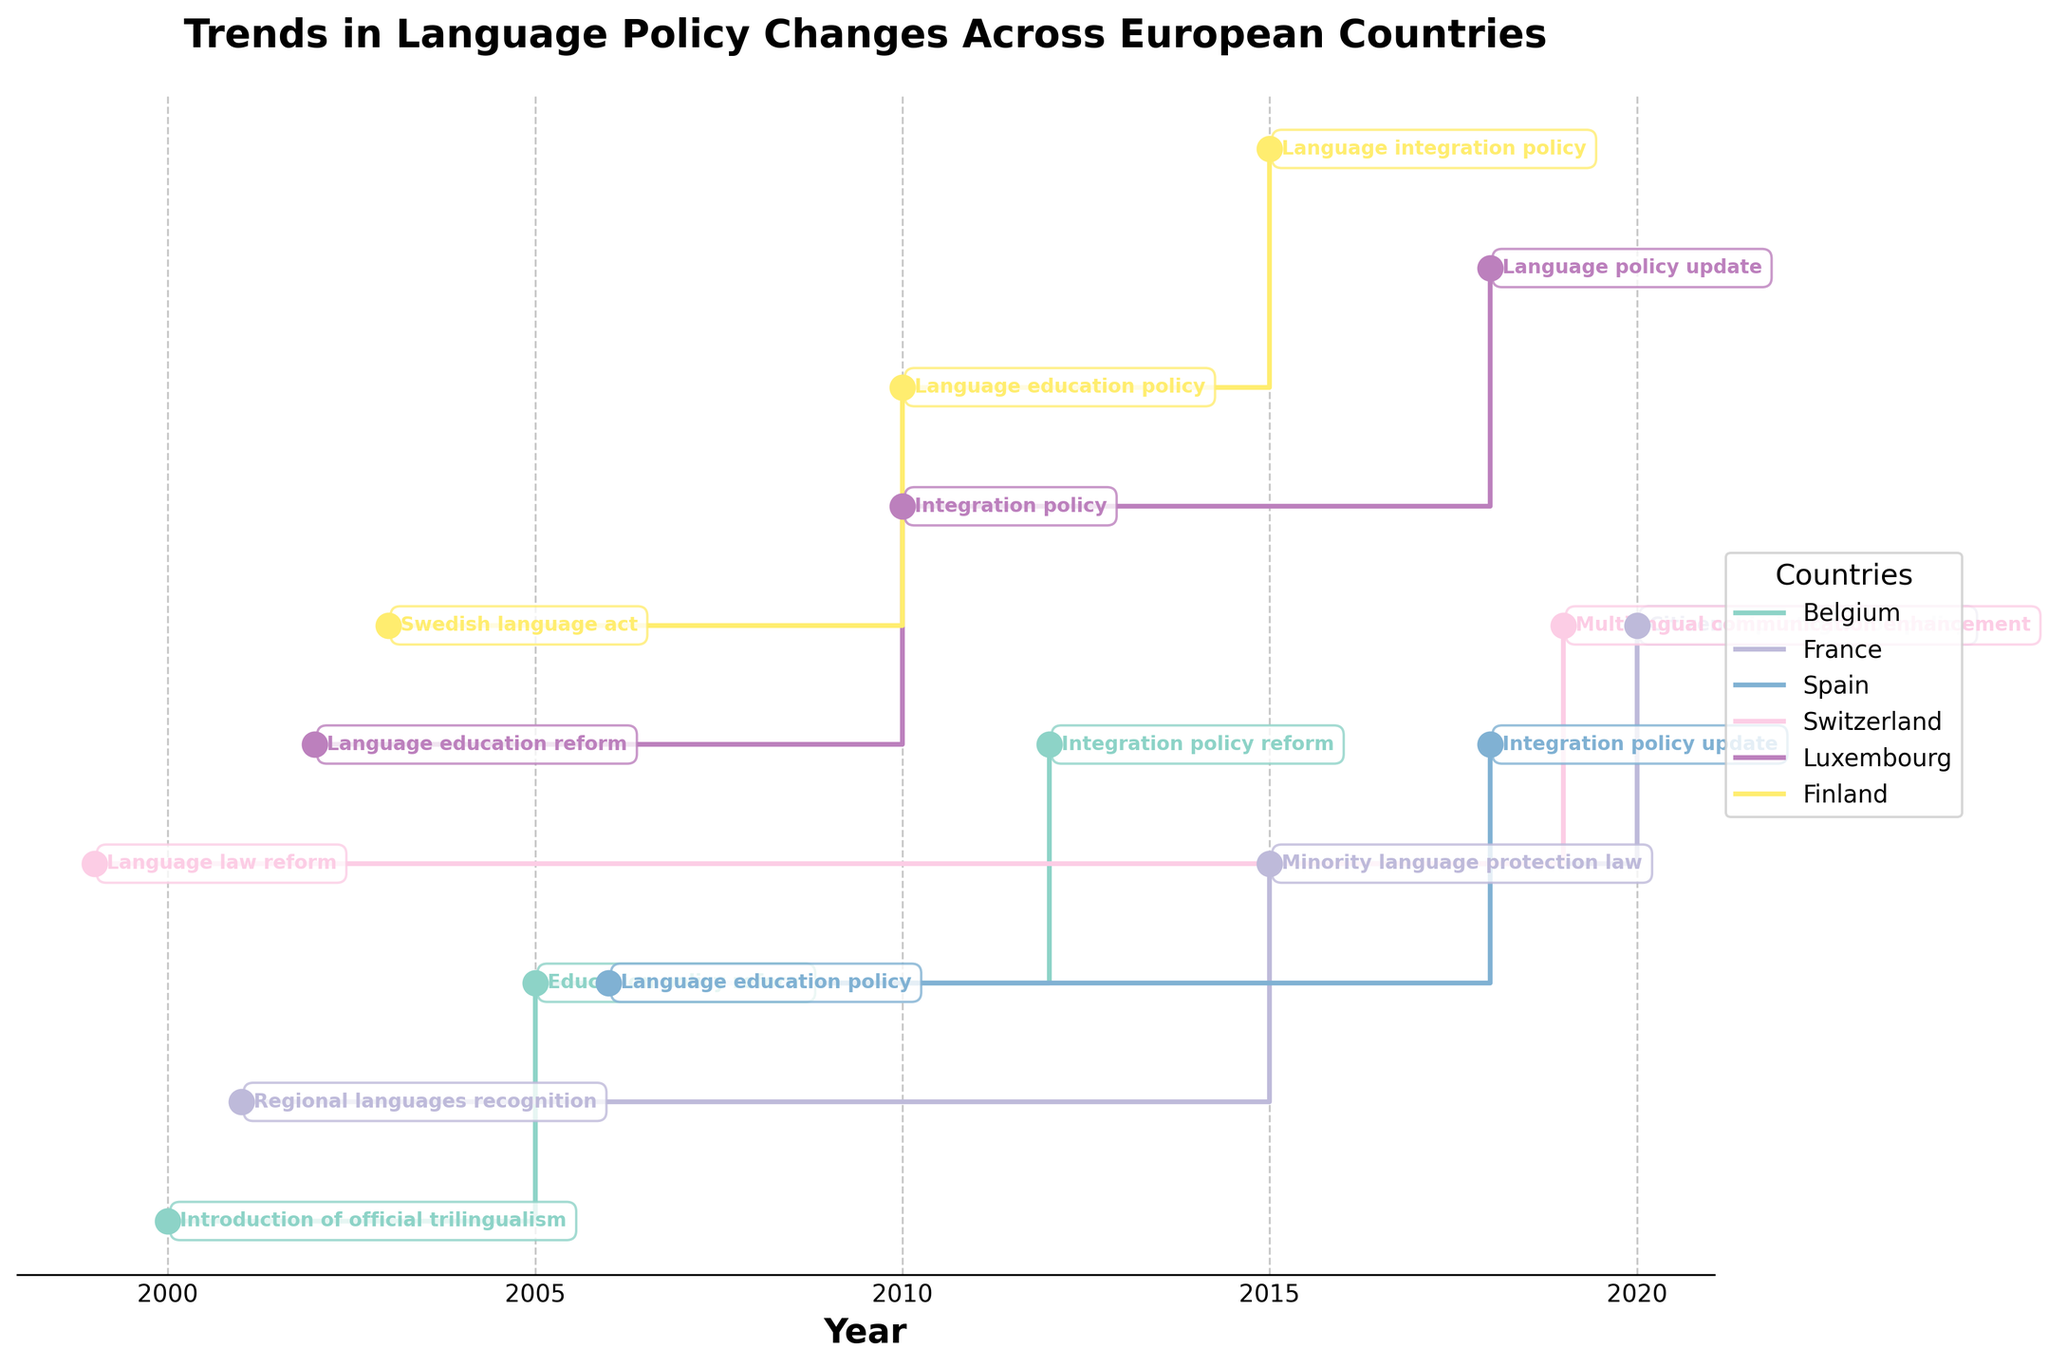What is the title of the stair plot? Look at the top part of the figure to identify its title. The title is usually bold and larger in font size compared to other text.
Answer: "Trends in Language Policy Changes Across European Countries" Which country had a language policy change in 1999? Look for the steps along the X-axis and locate the year 1999. Then trace vertically to find any annotations denoting a specific country and its policy change.
Answer: Switzerland How many countries are presented in the plot? Check the legend to see the list of countries included in the stair plot. Count the unique countries listed there.
Answer: 6 Which countries introduced trilingual education policies, and in what years? Look for the annotations mentioning "trilingual education" or "trilingualism" in the figure, and note the countries and corresponding years next to those annotations.
Answer: Belgium (2000), Luxembourg (2002) What is the latest policy change observed in the plot, and which country does it pertain to? Observe the farthest right annotation along the X-axis and identify the country and the policy change described.
Answer: Switzerland, 2019 How many language policy changes occurred in Belgium between 2000 and 2012? Identify all vertical markers specific to Belgium within the years 2000 and 2012 along the X-axis, and count them.
Answer: 3 Which country appears to have the most frequent language policy changes and how many are there? Count the number of steps (annotations) associated with each country by looking at the legend colors and matching them to the annotations. Identify which country has the highest count.
Answer: Belgium, 3 Are there any countries that have policy changes focused on education? If so, which ones and how many such policies are there in each? Look at the annotations and read for education-related keywords such as "education", "school curricula," "primary education," etc. Count these specific policy changes for each country.
Answer: Belgium (1), France (1), Spain (1), Luxembourg (1), Finland (1) Which countries have changed their policies to emphasize support for multilingualism in public services, and when? Look for annotations that specifically mention "public services" in terms like multilingualism. Note the countries and the respective years.
Answer: Belgium (2012), Luxembourg (2010) 